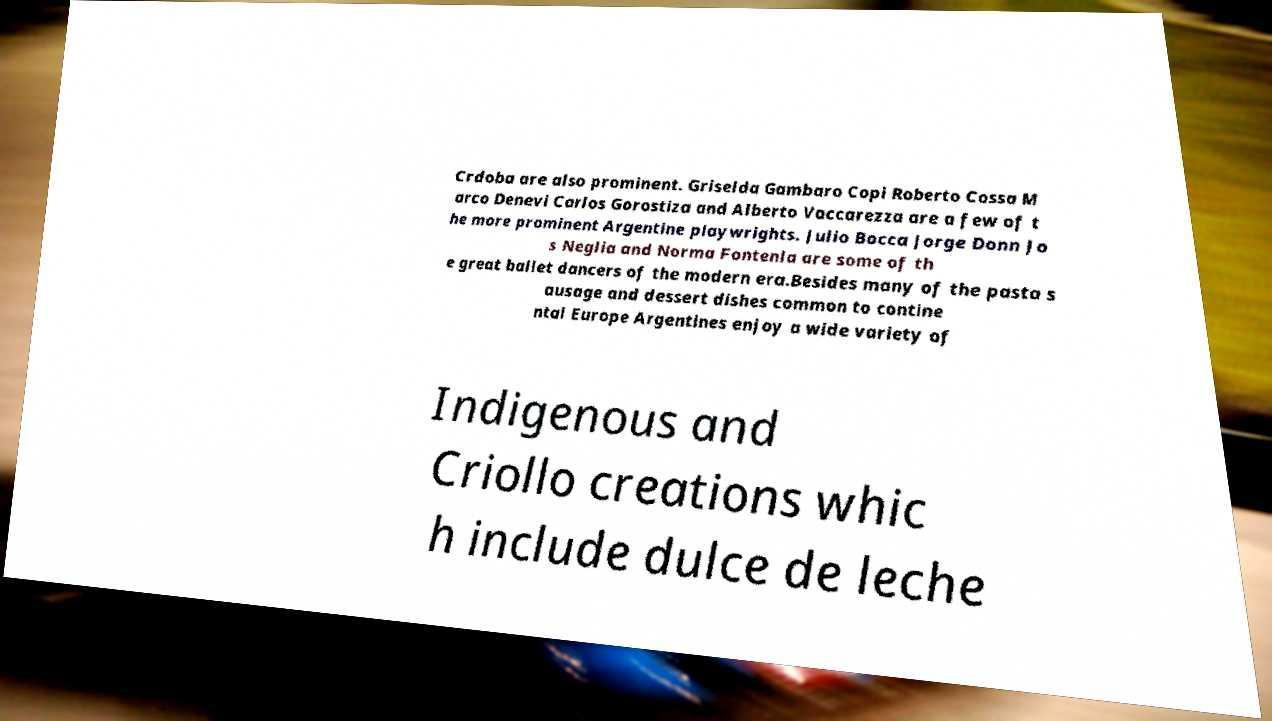Can you read and provide the text displayed in the image?This photo seems to have some interesting text. Can you extract and type it out for me? Crdoba are also prominent. Griselda Gambaro Copi Roberto Cossa M arco Denevi Carlos Gorostiza and Alberto Vaccarezza are a few of t he more prominent Argentine playwrights. Julio Bocca Jorge Donn Jo s Neglia and Norma Fontenla are some of th e great ballet dancers of the modern era.Besides many of the pasta s ausage and dessert dishes common to contine ntal Europe Argentines enjoy a wide variety of Indigenous and Criollo creations whic h include dulce de leche 